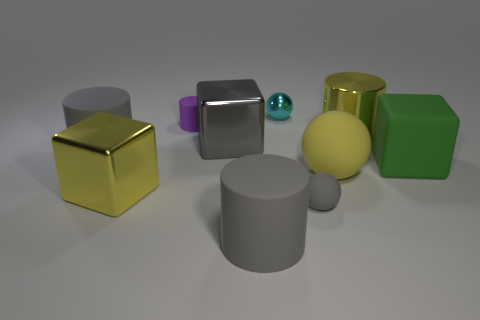Subtract all green cubes. How many gray cylinders are left? 2 Subtract all big yellow cylinders. How many cylinders are left? 3 Subtract 2 cylinders. How many cylinders are left? 2 Subtract all yellow cylinders. How many cylinders are left? 3 Subtract all cyan cubes. Subtract all red cylinders. How many cubes are left? 3 Subtract 0 blue cylinders. How many objects are left? 10 Subtract all blocks. How many objects are left? 7 Subtract all large gray cylinders. Subtract all large yellow balls. How many objects are left? 7 Add 3 big yellow shiny cubes. How many big yellow shiny cubes are left? 4 Add 3 yellow spheres. How many yellow spheres exist? 4 